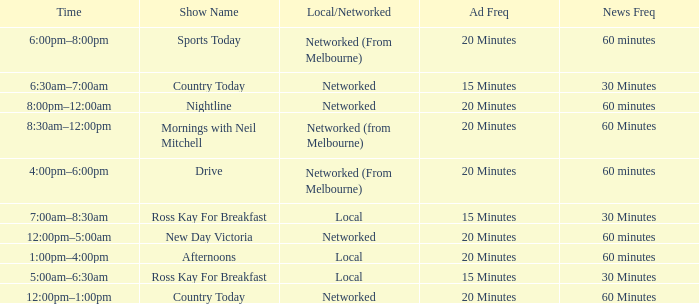What Ad Freq has a News Freq of 60 minutes, and a Local/Networked of local? 20 Minutes. 